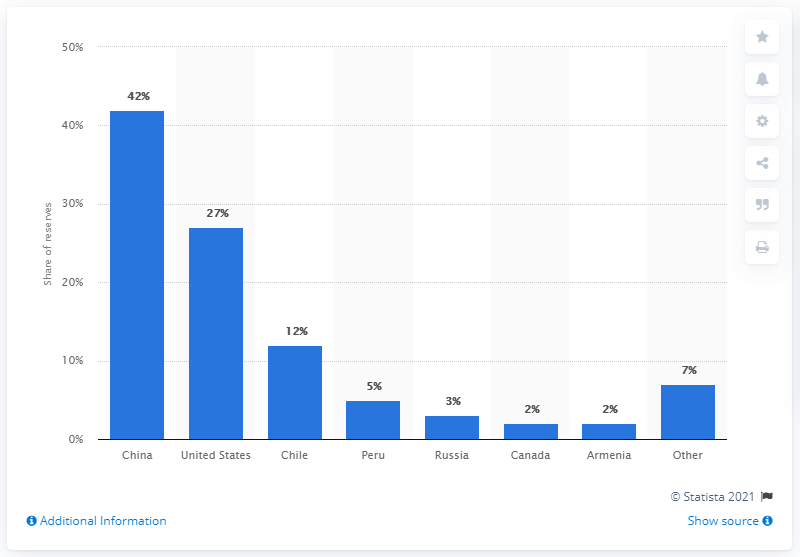Which country had the largest molybdenum reserves in 2016? In 2016, China had the largest molybdenum reserves, which is corroborated by the bar chart showing that China held a 42% share of the total global reserves, far surpassing any other country. 